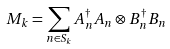<formula> <loc_0><loc_0><loc_500><loc_500>M _ { k } = \sum _ { n \in S _ { k } } A ^ { \dag } _ { n } A _ { n } \otimes B ^ { \dag } _ { n } B _ { n }</formula> 